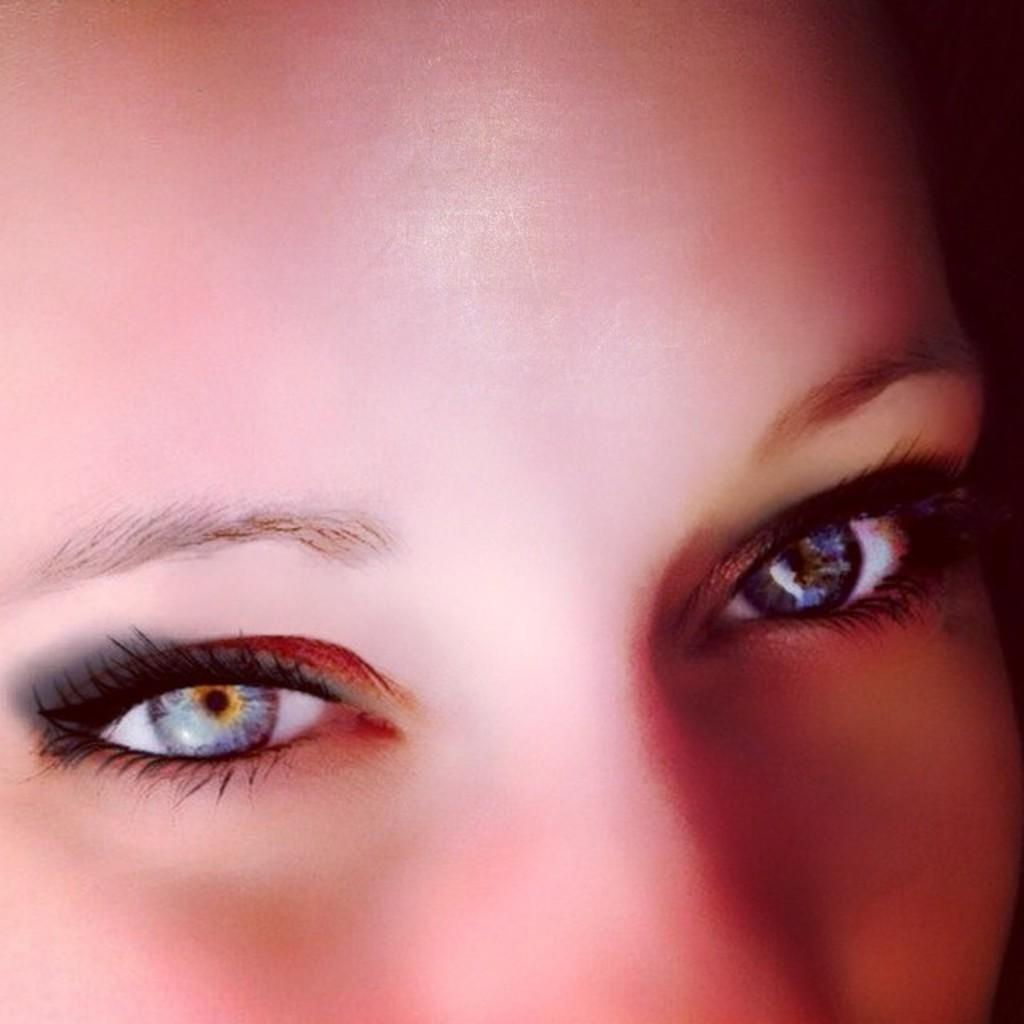What is the main subject of the image? There is a human face in the image. What facial features can be seen on the face? The face has eyes, eyebrows, and eyelashes. What type of wine is being served with the oatmeal in the image? There is no wine or oatmeal present in the image; it only features a human face with eyes, eyebrows, and eyelashes. 